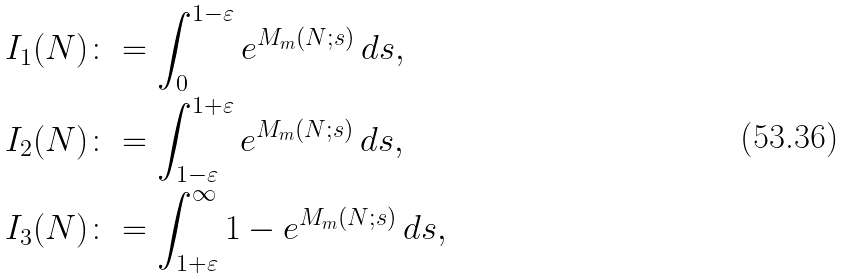<formula> <loc_0><loc_0><loc_500><loc_500>I _ { 1 } ( N ) \colon & = \int _ { 0 } ^ { 1 - \varepsilon } e ^ { M _ { m } ( N ; s ) } \, d s , \\ I _ { 2 } ( N ) \colon & = \int _ { 1 - \varepsilon } ^ { 1 + \varepsilon } e ^ { M _ { m } ( N ; s ) } \, d s , \\ I _ { 3 } ( N ) \colon & = \int _ { 1 + \varepsilon } ^ { \infty } 1 - e ^ { M _ { m } ( N ; s ) } \, d s ,</formula> 